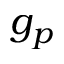<formula> <loc_0><loc_0><loc_500><loc_500>g _ { p }</formula> 